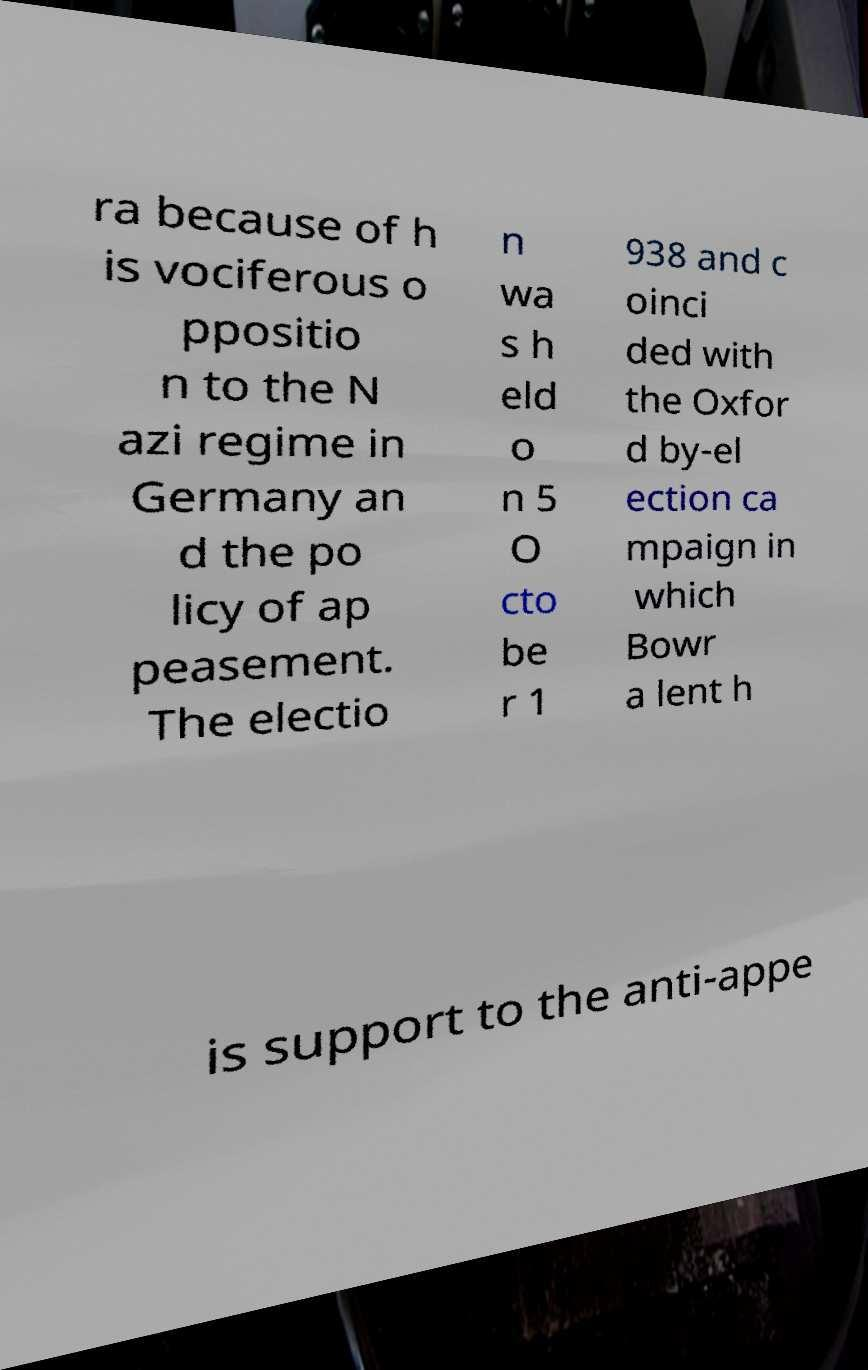What messages or text are displayed in this image? I need them in a readable, typed format. ra because of h is vociferous o ppositio n to the N azi regime in Germany an d the po licy of ap peasement. The electio n wa s h eld o n 5 O cto be r 1 938 and c oinci ded with the Oxfor d by-el ection ca mpaign in which Bowr a lent h is support to the anti-appe 